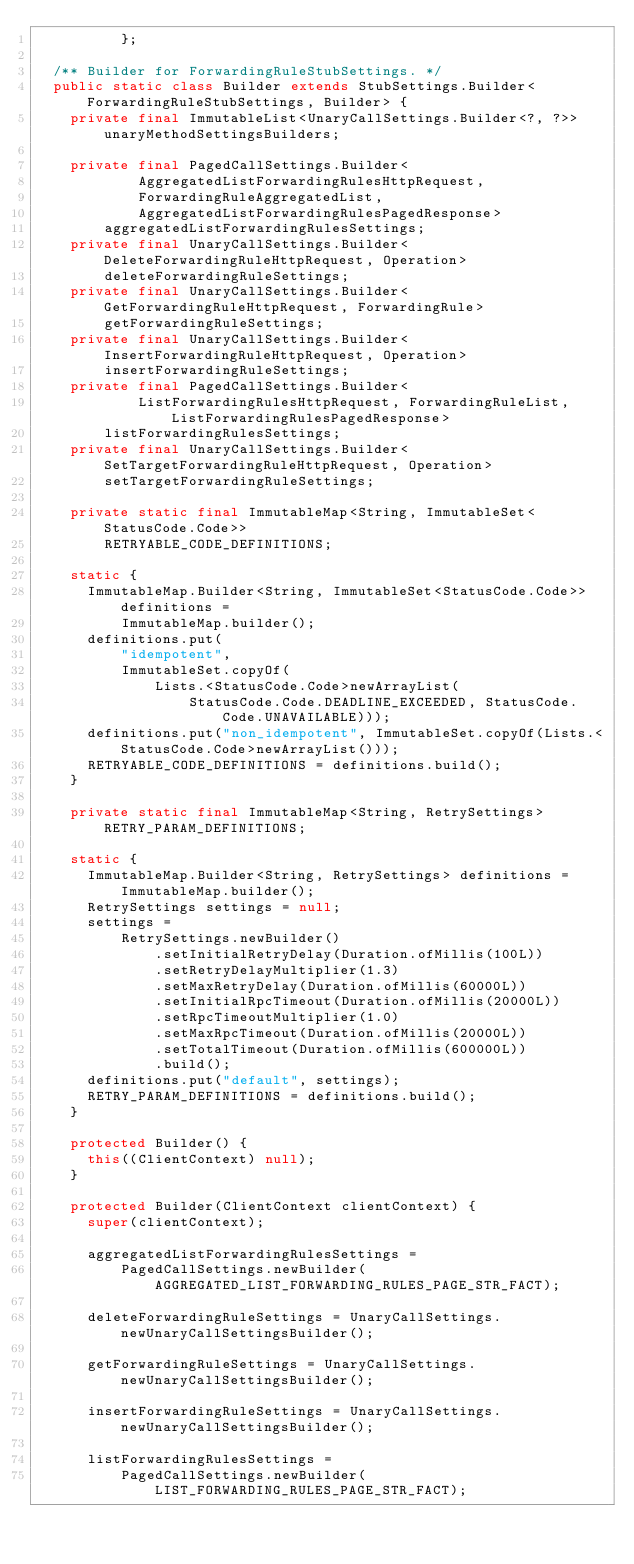<code> <loc_0><loc_0><loc_500><loc_500><_Java_>          };

  /** Builder for ForwardingRuleStubSettings. */
  public static class Builder extends StubSettings.Builder<ForwardingRuleStubSettings, Builder> {
    private final ImmutableList<UnaryCallSettings.Builder<?, ?>> unaryMethodSettingsBuilders;

    private final PagedCallSettings.Builder<
            AggregatedListForwardingRulesHttpRequest,
            ForwardingRuleAggregatedList,
            AggregatedListForwardingRulesPagedResponse>
        aggregatedListForwardingRulesSettings;
    private final UnaryCallSettings.Builder<DeleteForwardingRuleHttpRequest, Operation>
        deleteForwardingRuleSettings;
    private final UnaryCallSettings.Builder<GetForwardingRuleHttpRequest, ForwardingRule>
        getForwardingRuleSettings;
    private final UnaryCallSettings.Builder<InsertForwardingRuleHttpRequest, Operation>
        insertForwardingRuleSettings;
    private final PagedCallSettings.Builder<
            ListForwardingRulesHttpRequest, ForwardingRuleList, ListForwardingRulesPagedResponse>
        listForwardingRulesSettings;
    private final UnaryCallSettings.Builder<SetTargetForwardingRuleHttpRequest, Operation>
        setTargetForwardingRuleSettings;

    private static final ImmutableMap<String, ImmutableSet<StatusCode.Code>>
        RETRYABLE_CODE_DEFINITIONS;

    static {
      ImmutableMap.Builder<String, ImmutableSet<StatusCode.Code>> definitions =
          ImmutableMap.builder();
      definitions.put(
          "idempotent",
          ImmutableSet.copyOf(
              Lists.<StatusCode.Code>newArrayList(
                  StatusCode.Code.DEADLINE_EXCEEDED, StatusCode.Code.UNAVAILABLE)));
      definitions.put("non_idempotent", ImmutableSet.copyOf(Lists.<StatusCode.Code>newArrayList()));
      RETRYABLE_CODE_DEFINITIONS = definitions.build();
    }

    private static final ImmutableMap<String, RetrySettings> RETRY_PARAM_DEFINITIONS;

    static {
      ImmutableMap.Builder<String, RetrySettings> definitions = ImmutableMap.builder();
      RetrySettings settings = null;
      settings =
          RetrySettings.newBuilder()
              .setInitialRetryDelay(Duration.ofMillis(100L))
              .setRetryDelayMultiplier(1.3)
              .setMaxRetryDelay(Duration.ofMillis(60000L))
              .setInitialRpcTimeout(Duration.ofMillis(20000L))
              .setRpcTimeoutMultiplier(1.0)
              .setMaxRpcTimeout(Duration.ofMillis(20000L))
              .setTotalTimeout(Duration.ofMillis(600000L))
              .build();
      definitions.put("default", settings);
      RETRY_PARAM_DEFINITIONS = definitions.build();
    }

    protected Builder() {
      this((ClientContext) null);
    }

    protected Builder(ClientContext clientContext) {
      super(clientContext);

      aggregatedListForwardingRulesSettings =
          PagedCallSettings.newBuilder(AGGREGATED_LIST_FORWARDING_RULES_PAGE_STR_FACT);

      deleteForwardingRuleSettings = UnaryCallSettings.newUnaryCallSettingsBuilder();

      getForwardingRuleSettings = UnaryCallSettings.newUnaryCallSettingsBuilder();

      insertForwardingRuleSettings = UnaryCallSettings.newUnaryCallSettingsBuilder();

      listForwardingRulesSettings =
          PagedCallSettings.newBuilder(LIST_FORWARDING_RULES_PAGE_STR_FACT);
</code> 